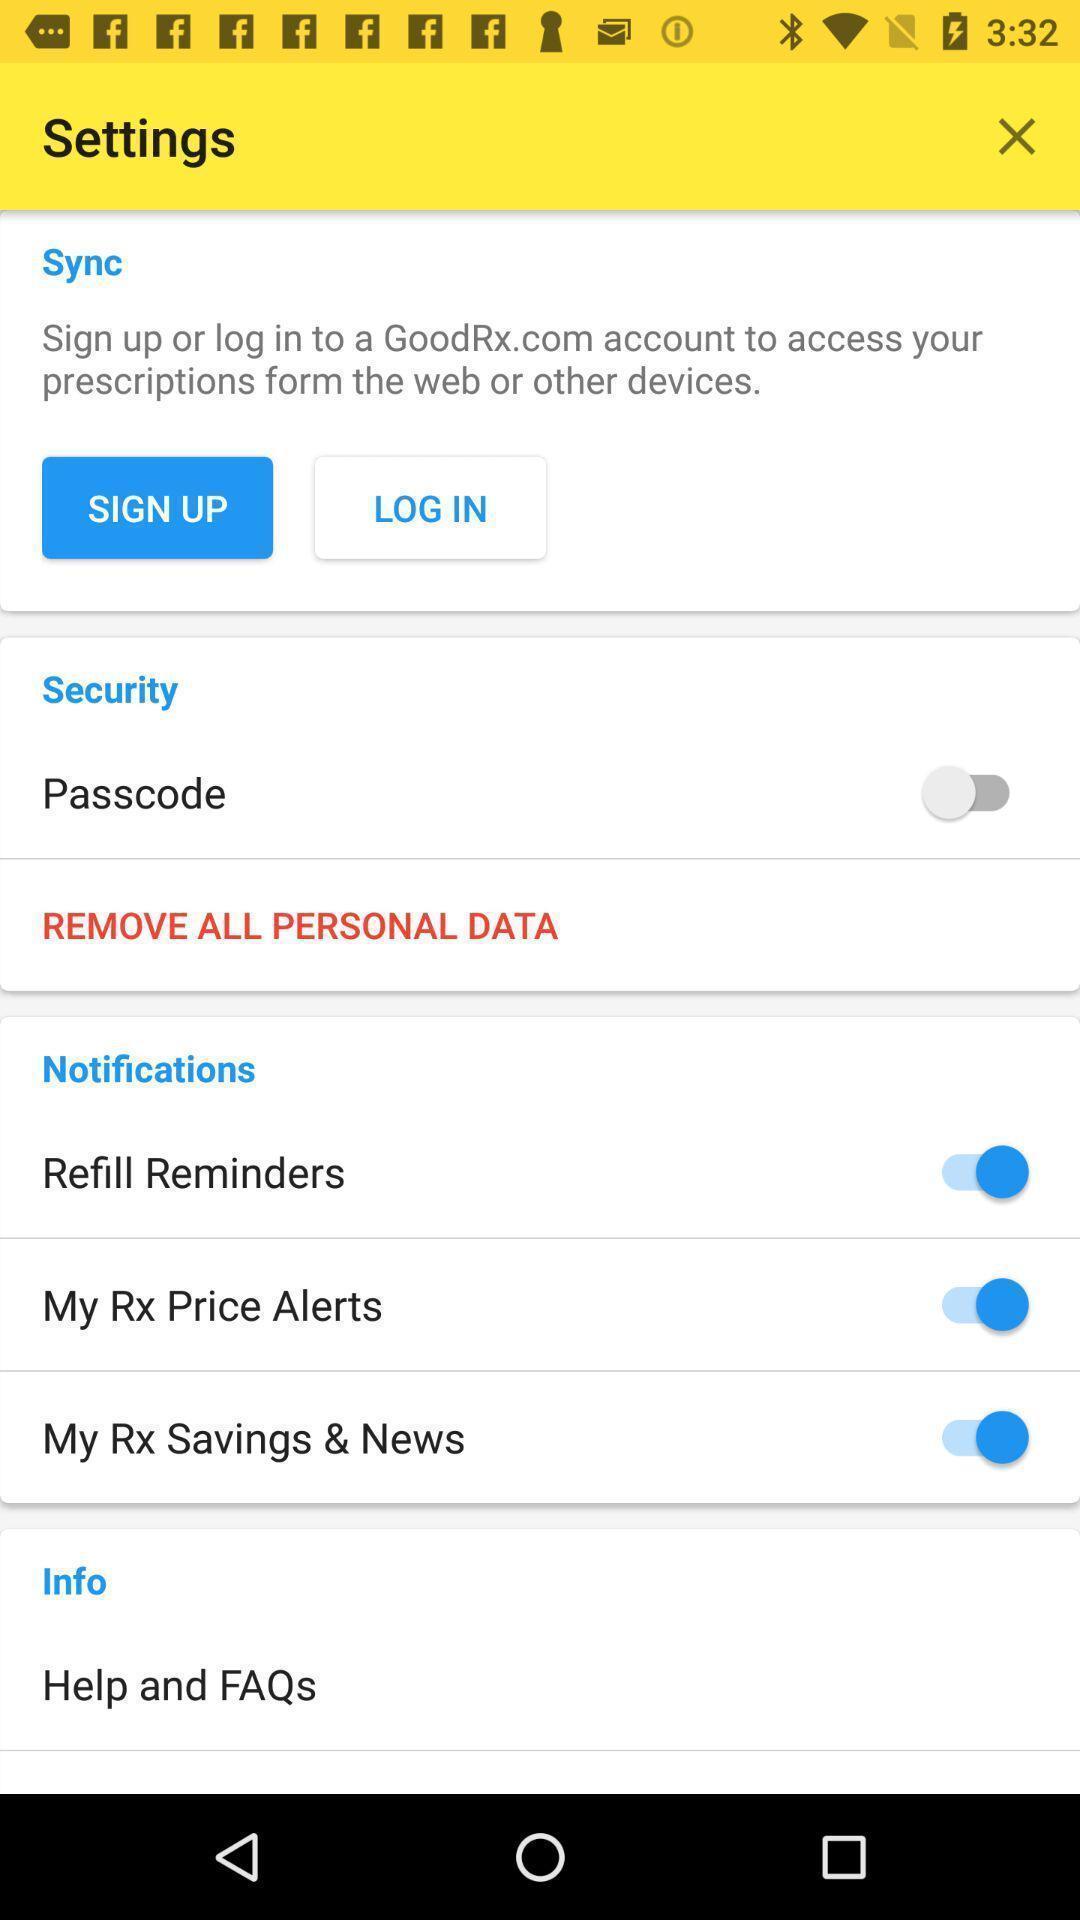Tell me about the visual elements in this screen capture. Settings page with multiple options. 